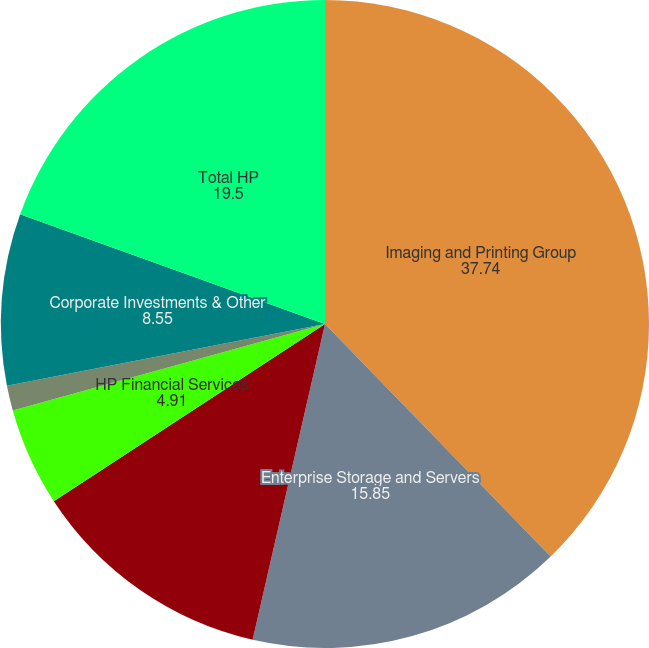Convert chart. <chart><loc_0><loc_0><loc_500><loc_500><pie_chart><fcel>Imaging and Printing Group<fcel>Enterprise Storage and Servers<fcel>Personal Systems Group<fcel>HP Financial Services<fcel>Software<fcel>Corporate Investments & Other<fcel>Total HP<nl><fcel>37.74%<fcel>15.85%<fcel>12.2%<fcel>4.91%<fcel>1.26%<fcel>8.55%<fcel>19.5%<nl></chart> 